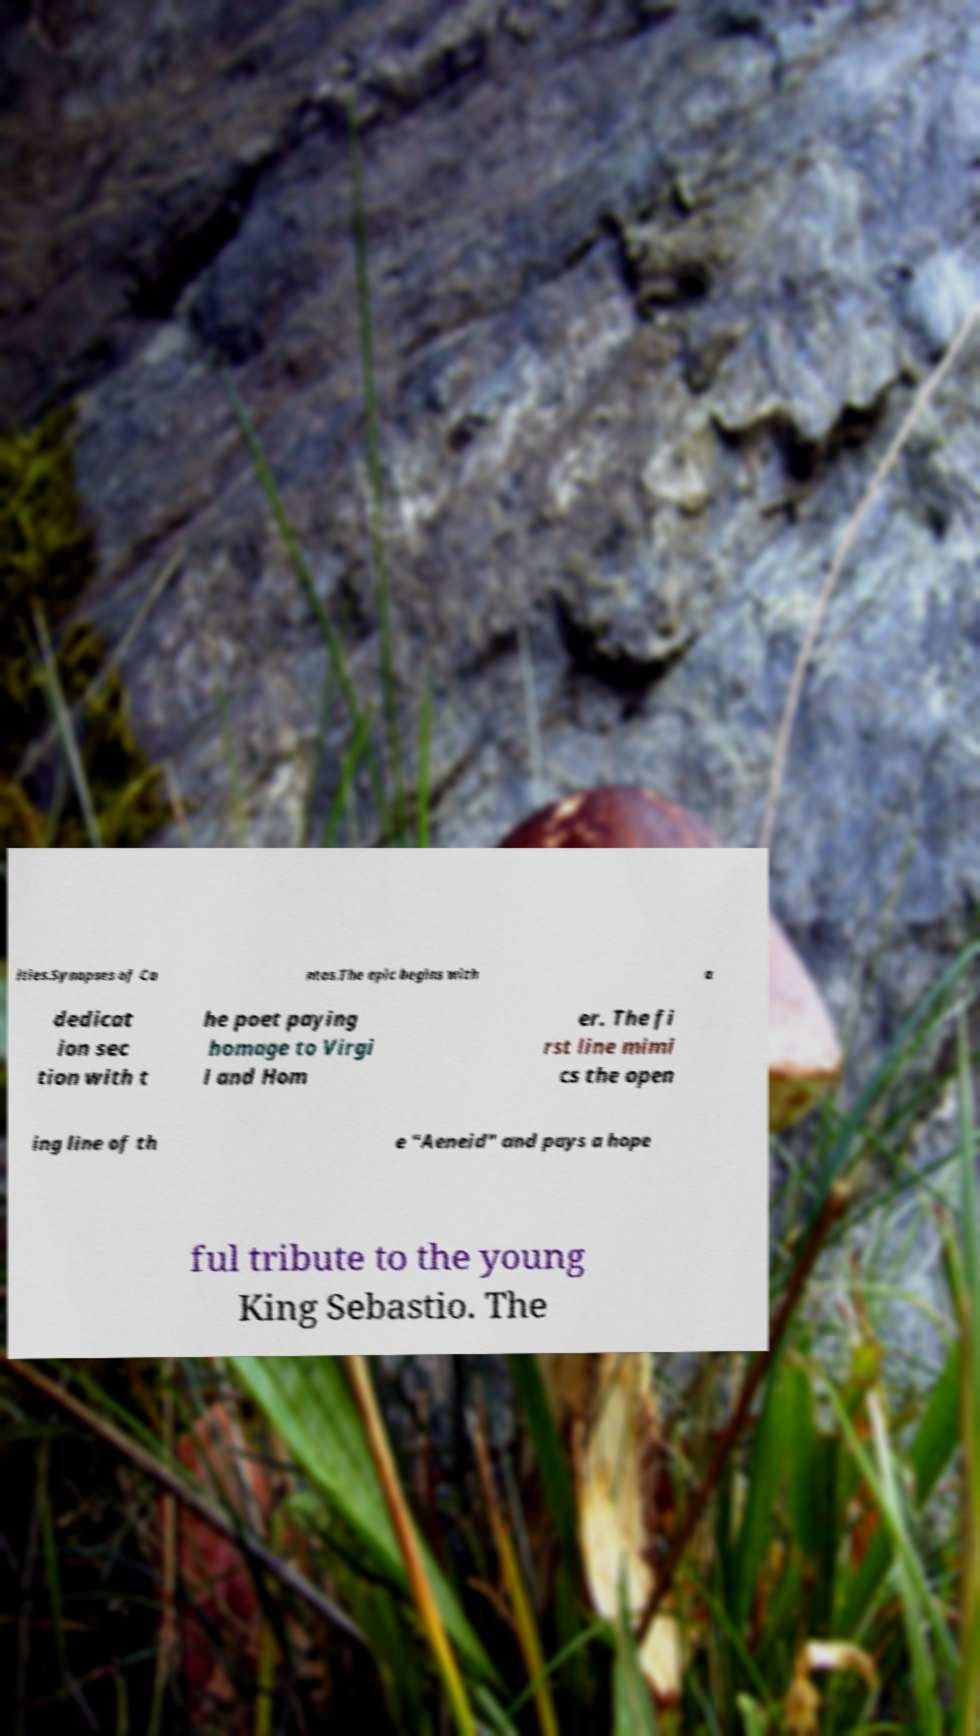For documentation purposes, I need the text within this image transcribed. Could you provide that? ities.Synopses of Ca ntos.The epic begins with a dedicat ion sec tion with t he poet paying homage to Virgi l and Hom er. The fi rst line mimi cs the open ing line of th e "Aeneid" and pays a hope ful tribute to the young King Sebastio. The 